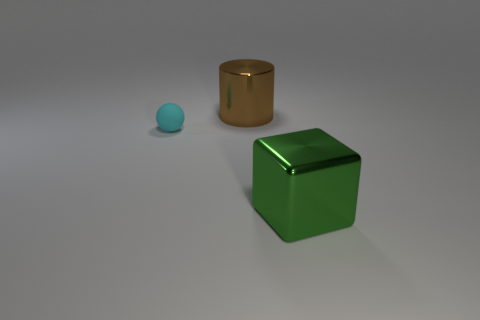Are there any green metal things that have the same size as the shiny cylinder?
Your response must be concise. Yes. Are there any other things that have the same size as the matte sphere?
Offer a terse response. No. What number of things are either small gray rubber things or large metallic objects that are behind the large green metal cube?
Give a very brief answer. 1. What is the size of the brown metal cylinder that is left of the large shiny thing in front of the cylinder?
Keep it short and to the point. Large. Is the number of cyan spheres that are in front of the rubber thing the same as the number of matte objects to the right of the metallic cylinder?
Provide a succinct answer. Yes. Are there any metallic things in front of the metallic thing behind the big metal block?
Provide a succinct answer. Yes. What is the shape of the thing that is made of the same material as the large cube?
Provide a short and direct response. Cylinder. What is the big object behind the thing in front of the tiny rubber thing made of?
Your response must be concise. Metal. How many other objects are there of the same shape as the big green metal object?
Make the answer very short. 0. There is a object that is both right of the tiny cyan object and behind the big green shiny block; what shape is it?
Your answer should be compact. Cylinder. 